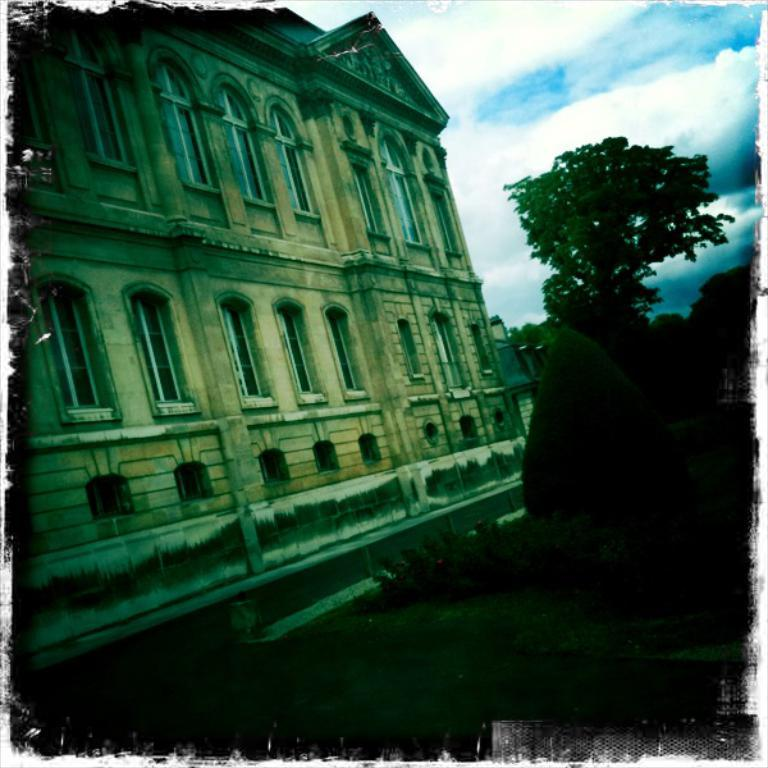What type of vegetation is on the right side of the image? There are plants and trees on the right side of the image. What type of structure is on the left side of the image? There is a building on the left side of the image. What is visible in the sky at the top right of the image? The sky with clouds is visible at the top right of the image. What type of terrain is at the bottom of the image? There is a grassland at the bottom of the image. What type of toothpaste is being used to clean the plants in the image? There is no toothpaste present in the image, and plants do not require cleaning with toothpaste. What selection of poisonous plants can be seen in the image? There are no poisonous plants visible in the image, and the image does not mention any specific plants. 